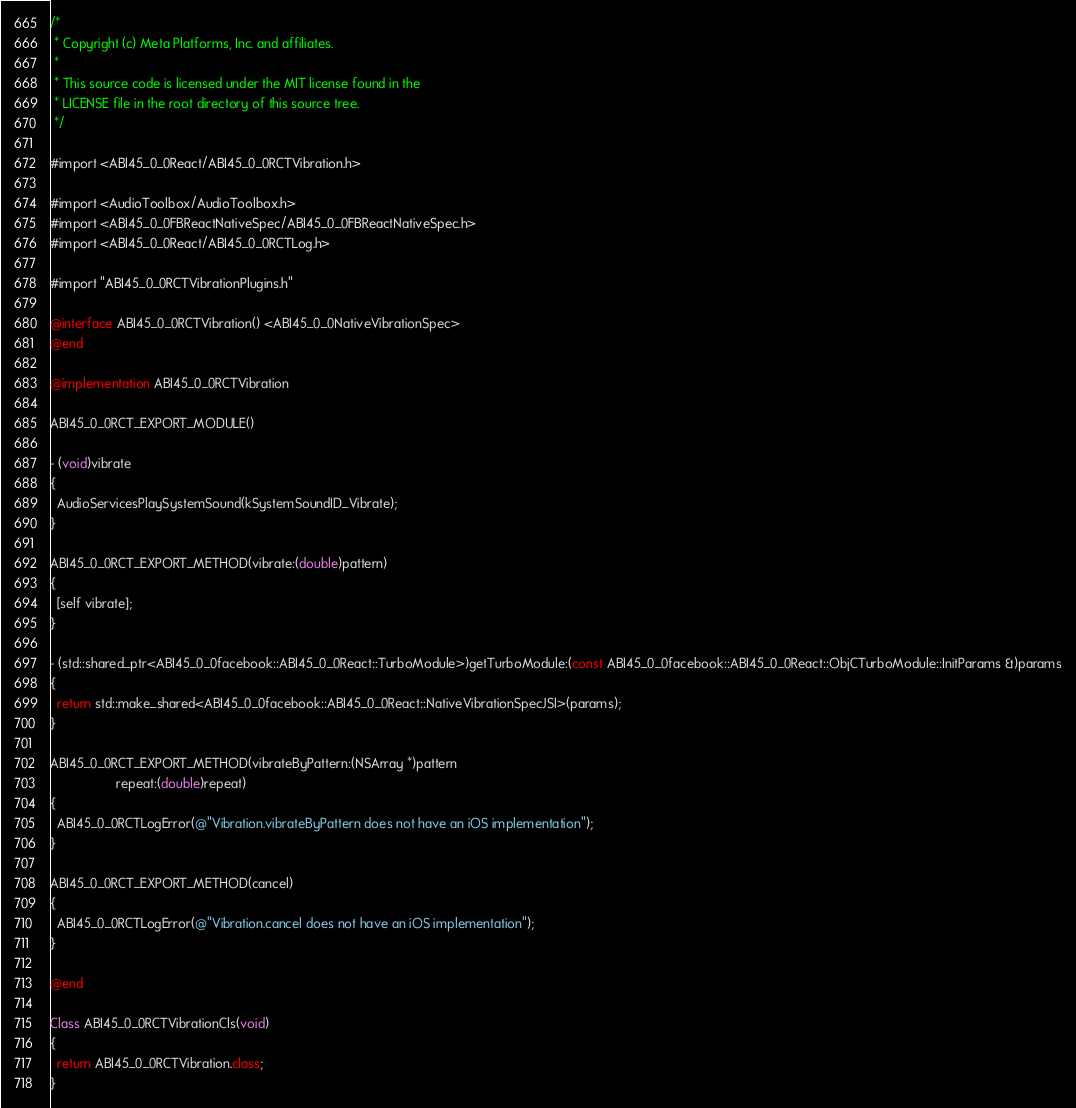Convert code to text. <code><loc_0><loc_0><loc_500><loc_500><_ObjectiveC_>/*
 * Copyright (c) Meta Platforms, Inc. and affiliates.
 *
 * This source code is licensed under the MIT license found in the
 * LICENSE file in the root directory of this source tree.
 */

#import <ABI45_0_0React/ABI45_0_0RCTVibration.h>

#import <AudioToolbox/AudioToolbox.h>
#import <ABI45_0_0FBReactNativeSpec/ABI45_0_0FBReactNativeSpec.h>
#import <ABI45_0_0React/ABI45_0_0RCTLog.h>

#import "ABI45_0_0RCTVibrationPlugins.h"

@interface ABI45_0_0RCTVibration() <ABI45_0_0NativeVibrationSpec>
@end

@implementation ABI45_0_0RCTVibration

ABI45_0_0RCT_EXPORT_MODULE()

- (void)vibrate
{
  AudioServicesPlaySystemSound(kSystemSoundID_Vibrate);
}

ABI45_0_0RCT_EXPORT_METHOD(vibrate:(double)pattern)
{
  [self vibrate];
}

- (std::shared_ptr<ABI45_0_0facebook::ABI45_0_0React::TurboModule>)getTurboModule:(const ABI45_0_0facebook::ABI45_0_0React::ObjCTurboModule::InitParams &)params
{
  return std::make_shared<ABI45_0_0facebook::ABI45_0_0React::NativeVibrationSpecJSI>(params);
}

ABI45_0_0RCT_EXPORT_METHOD(vibrateByPattern:(NSArray *)pattern
                  repeat:(double)repeat)
{
  ABI45_0_0RCTLogError(@"Vibration.vibrateByPattern does not have an iOS implementation");
}

ABI45_0_0RCT_EXPORT_METHOD(cancel)
{
  ABI45_0_0RCTLogError(@"Vibration.cancel does not have an iOS implementation");
}

@end

Class ABI45_0_0RCTVibrationCls(void)
{
  return ABI45_0_0RCTVibration.class;
}
</code> 